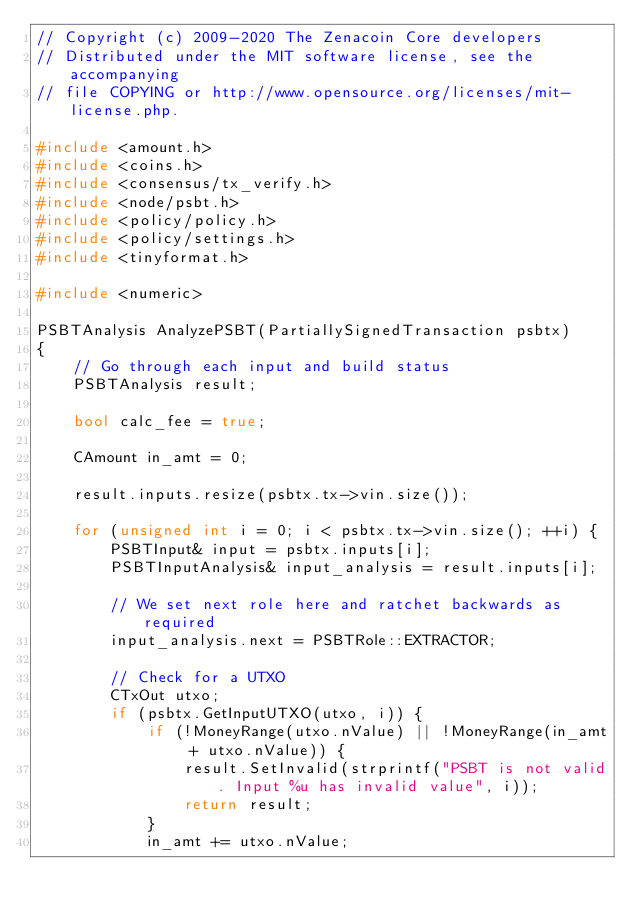<code> <loc_0><loc_0><loc_500><loc_500><_C++_>// Copyright (c) 2009-2020 The Zenacoin Core developers
// Distributed under the MIT software license, see the accompanying
// file COPYING or http://www.opensource.org/licenses/mit-license.php.

#include <amount.h>
#include <coins.h>
#include <consensus/tx_verify.h>
#include <node/psbt.h>
#include <policy/policy.h>
#include <policy/settings.h>
#include <tinyformat.h>

#include <numeric>

PSBTAnalysis AnalyzePSBT(PartiallySignedTransaction psbtx)
{
    // Go through each input and build status
    PSBTAnalysis result;

    bool calc_fee = true;

    CAmount in_amt = 0;

    result.inputs.resize(psbtx.tx->vin.size());

    for (unsigned int i = 0; i < psbtx.tx->vin.size(); ++i) {
        PSBTInput& input = psbtx.inputs[i];
        PSBTInputAnalysis& input_analysis = result.inputs[i];

        // We set next role here and ratchet backwards as required
        input_analysis.next = PSBTRole::EXTRACTOR;

        // Check for a UTXO
        CTxOut utxo;
        if (psbtx.GetInputUTXO(utxo, i)) {
            if (!MoneyRange(utxo.nValue) || !MoneyRange(in_amt + utxo.nValue)) {
                result.SetInvalid(strprintf("PSBT is not valid. Input %u has invalid value", i));
                return result;
            }
            in_amt += utxo.nValue;</code> 